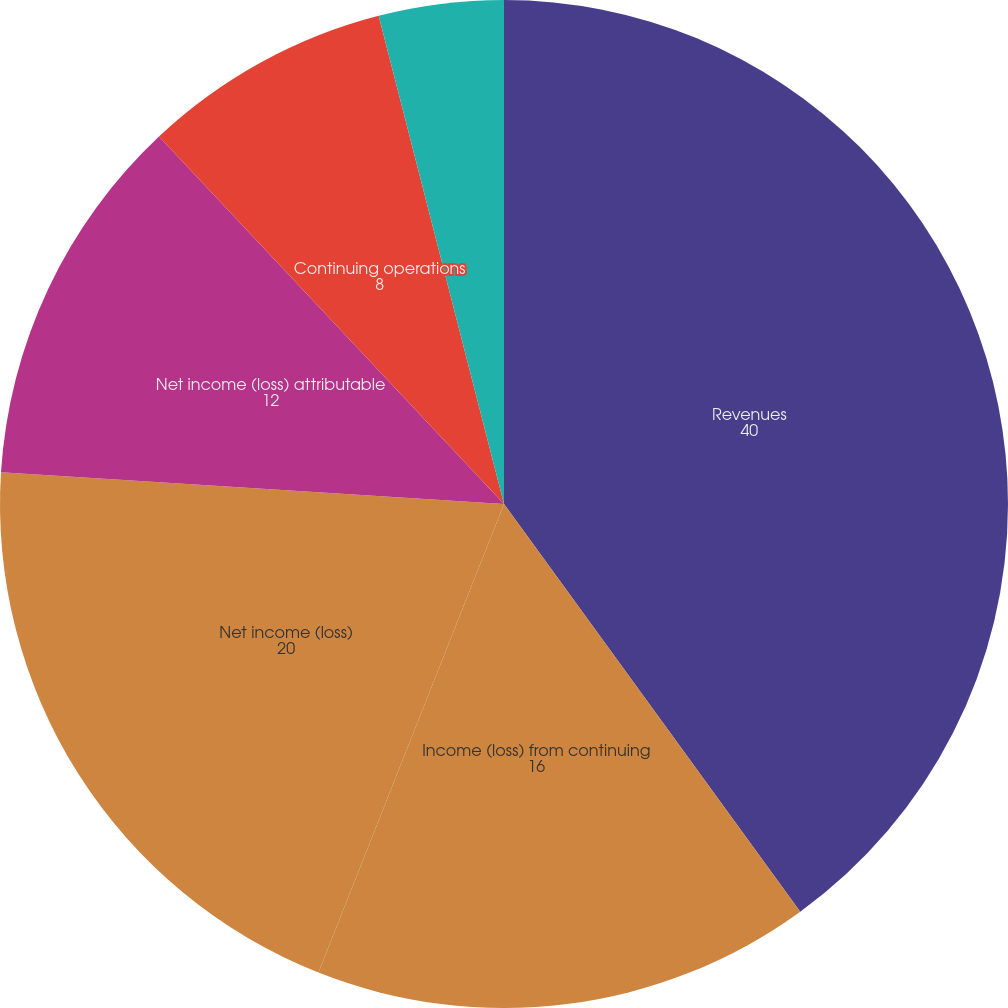Convert chart. <chart><loc_0><loc_0><loc_500><loc_500><pie_chart><fcel>Revenues<fcel>Income (loss) from continuing<fcel>Net income (loss)<fcel>Net income (loss) attributable<fcel>Continuing operations<fcel>Discontinued operations<fcel>Dividends declared per common<nl><fcel>40.0%<fcel>16.0%<fcel>20.0%<fcel>12.0%<fcel>8.0%<fcel>0.0%<fcel>4.0%<nl></chart> 